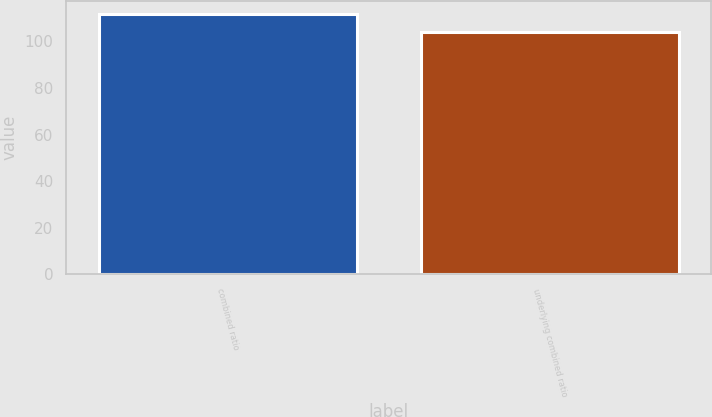Convert chart. <chart><loc_0><loc_0><loc_500><loc_500><bar_chart><fcel>combined ratio<fcel>underlying combined ratio<nl><fcel>111.6<fcel>103.9<nl></chart> 